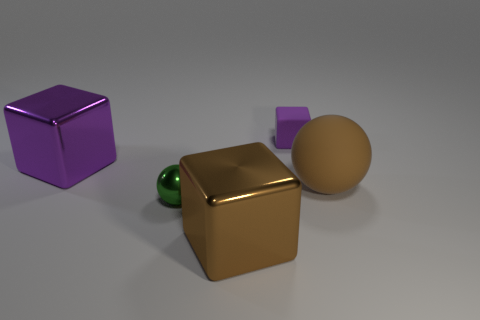How many shiny objects are the same color as the big rubber sphere?
Provide a short and direct response. 1. There is another block that is the same size as the brown shiny block; what is its material?
Provide a succinct answer. Metal. What shape is the brown object behind the big cube to the right of the cube that is on the left side of the small metallic thing?
Your answer should be compact. Sphere. What material is the large brown thing that is the same shape as the tiny green shiny thing?
Offer a terse response. Rubber. What number of purple objects are there?
Make the answer very short. 2. There is a tiny object on the left side of the small purple cube; what shape is it?
Give a very brief answer. Sphere. There is a tiny thing that is on the left side of the metal block to the right of the purple metallic block that is in front of the purple matte cube; what is its color?
Keep it short and to the point. Green. What is the shape of the purple thing that is made of the same material as the tiny sphere?
Your answer should be very brief. Cube. Are there fewer big brown objects than brown balls?
Offer a very short reply. No. Is the material of the tiny sphere the same as the brown cube?
Ensure brevity in your answer.  Yes. 